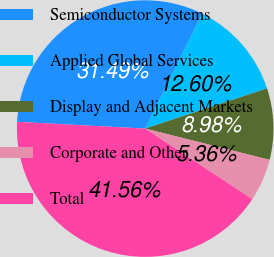Convert chart. <chart><loc_0><loc_0><loc_500><loc_500><pie_chart><fcel>Semiconductor Systems<fcel>Applied Global Services<fcel>Display and Adjacent Markets<fcel>Corporate and Other<fcel>Total<nl><fcel>31.49%<fcel>12.6%<fcel>8.98%<fcel>5.36%<fcel>41.56%<nl></chart> 